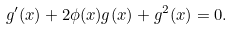<formula> <loc_0><loc_0><loc_500><loc_500>g ^ { \prime } ( x ) + 2 \phi ( x ) g ( x ) + g ^ { 2 } ( x ) = 0 .</formula> 